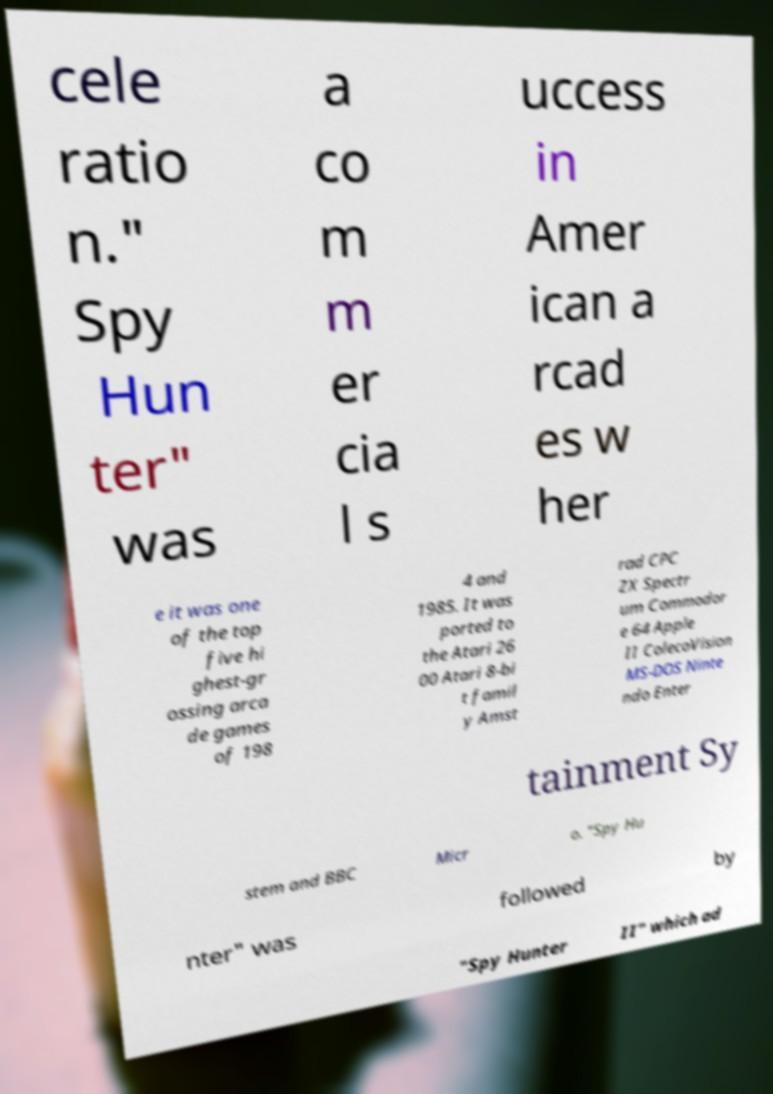Could you assist in decoding the text presented in this image and type it out clearly? cele ratio n." Spy Hun ter" was a co m m er cia l s uccess in Amer ican a rcad es w her e it was one of the top five hi ghest-gr ossing arca de games of 198 4 and 1985. It was ported to the Atari 26 00 Atari 8-bi t famil y Amst rad CPC ZX Spectr um Commodor e 64 Apple II ColecoVision MS-DOS Ninte ndo Enter tainment Sy stem and BBC Micr o. "Spy Hu nter" was followed by "Spy Hunter II" which ad 